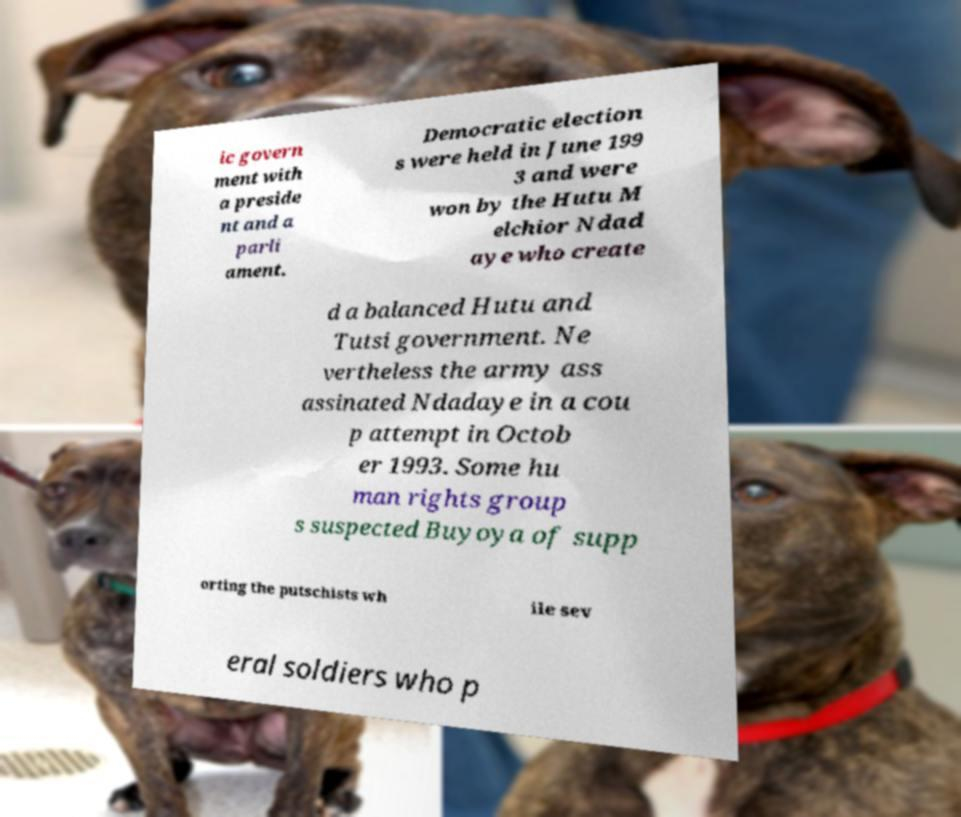What messages or text are displayed in this image? I need them in a readable, typed format. ic govern ment with a preside nt and a parli ament. Democratic election s were held in June 199 3 and were won by the Hutu M elchior Ndad aye who create d a balanced Hutu and Tutsi government. Ne vertheless the army ass assinated Ndadaye in a cou p attempt in Octob er 1993. Some hu man rights group s suspected Buyoya of supp orting the putschists wh ile sev eral soldiers who p 